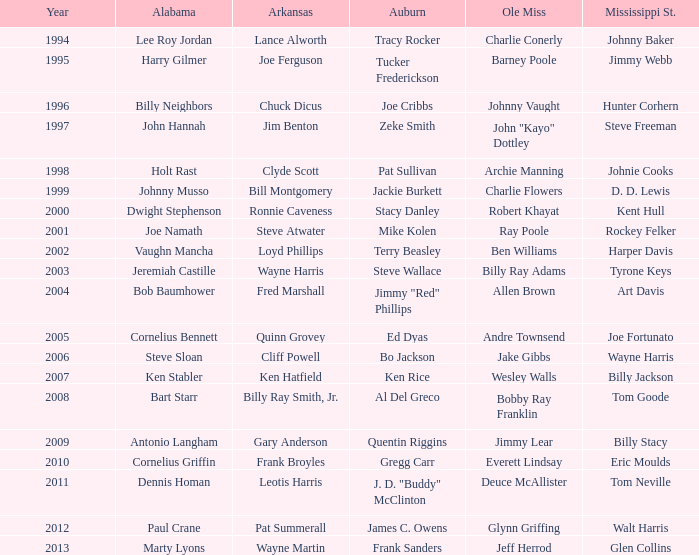Who was the Ole Miss player associated with Chuck Dicus? Johnny Vaught. 